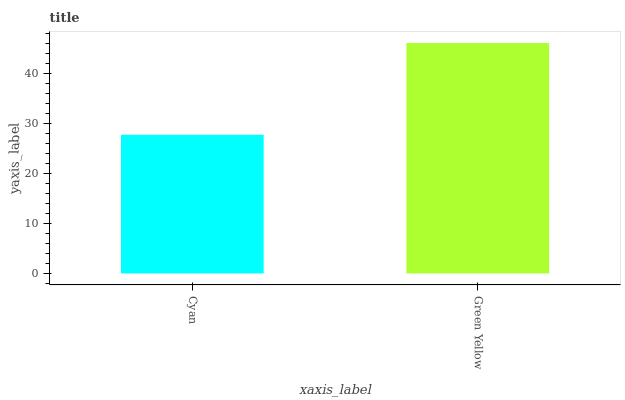Is Cyan the minimum?
Answer yes or no. Yes. Is Green Yellow the maximum?
Answer yes or no. Yes. Is Green Yellow the minimum?
Answer yes or no. No. Is Green Yellow greater than Cyan?
Answer yes or no. Yes. Is Cyan less than Green Yellow?
Answer yes or no. Yes. Is Cyan greater than Green Yellow?
Answer yes or no. No. Is Green Yellow less than Cyan?
Answer yes or no. No. Is Green Yellow the high median?
Answer yes or no. Yes. Is Cyan the low median?
Answer yes or no. Yes. Is Cyan the high median?
Answer yes or no. No. Is Green Yellow the low median?
Answer yes or no. No. 